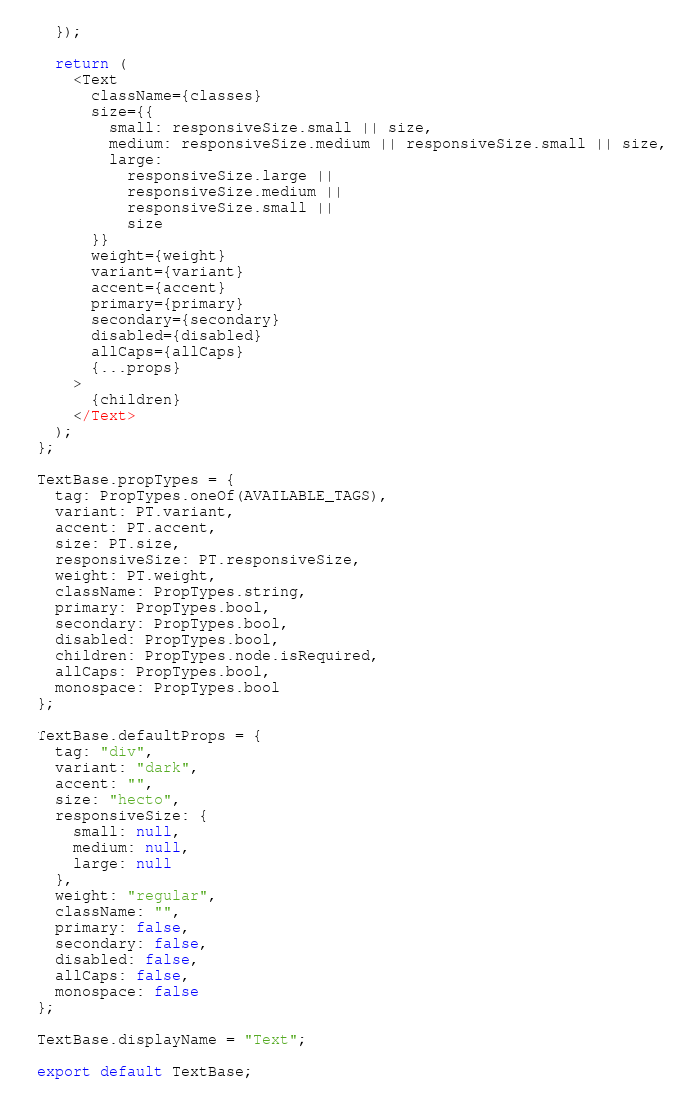<code> <loc_0><loc_0><loc_500><loc_500><_JavaScript_>  });

  return (
    <Text
      className={classes}
      size={{
        small: responsiveSize.small || size,
        medium: responsiveSize.medium || responsiveSize.small || size,
        large:
          responsiveSize.large ||
          responsiveSize.medium ||
          responsiveSize.small ||
          size
      }}
      weight={weight}
      variant={variant}
      accent={accent}
      primary={primary}
      secondary={secondary}
      disabled={disabled}
      allCaps={allCaps}
      {...props}
    >
      {children}
    </Text>
  );
};

TextBase.propTypes = {
  tag: PropTypes.oneOf(AVAILABLE_TAGS),
  variant: PT.variant,
  accent: PT.accent,
  size: PT.size,
  responsiveSize: PT.responsiveSize,
  weight: PT.weight,
  className: PropTypes.string,
  primary: PropTypes.bool,
  secondary: PropTypes.bool,
  disabled: PropTypes.bool,
  children: PropTypes.node.isRequired,
  allCaps: PropTypes.bool,
  monospace: PropTypes.bool
};

TextBase.defaultProps = {
  tag: "div",
  variant: "dark",
  accent: "",
  size: "hecto",
  responsiveSize: {
    small: null,
    medium: null,
    large: null
  },
  weight: "regular",
  className: "",
  primary: false,
  secondary: false,
  disabled: false,
  allCaps: false,
  monospace: false
};

TextBase.displayName = "Text";

export default TextBase;
</code> 